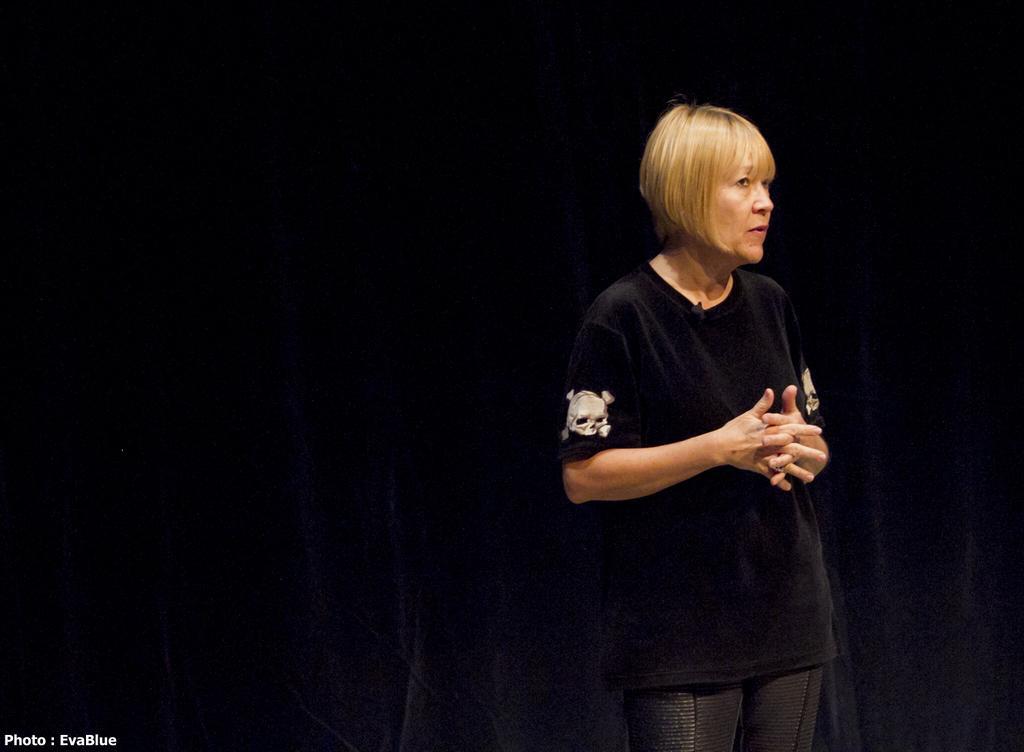Please provide a concise description of this image. In the image a woman is standing. 